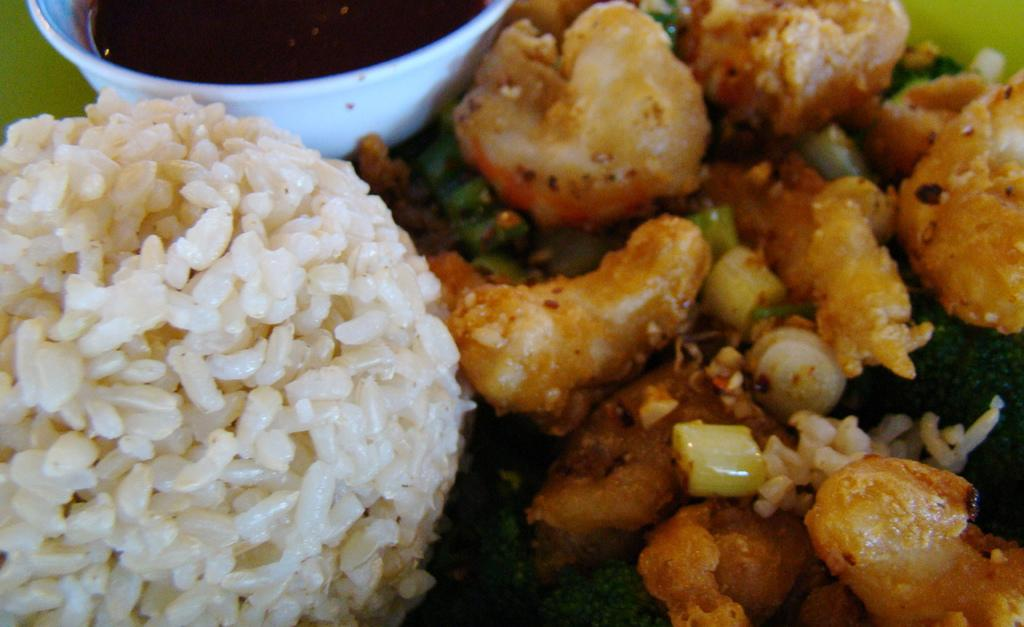What types of food can be seen in the image? There are food items in the image. What is the color of the bowl containing the sauce? The sauce is in a white-colored bowl. What colors are present in the food? The food has brown, white, and green colors. What type of train can be seen in the image? There is no train present in the image. What attraction is visible in the background of the image? There is no background or attraction mentioned in the provided facts, so we cannot answer this question. 